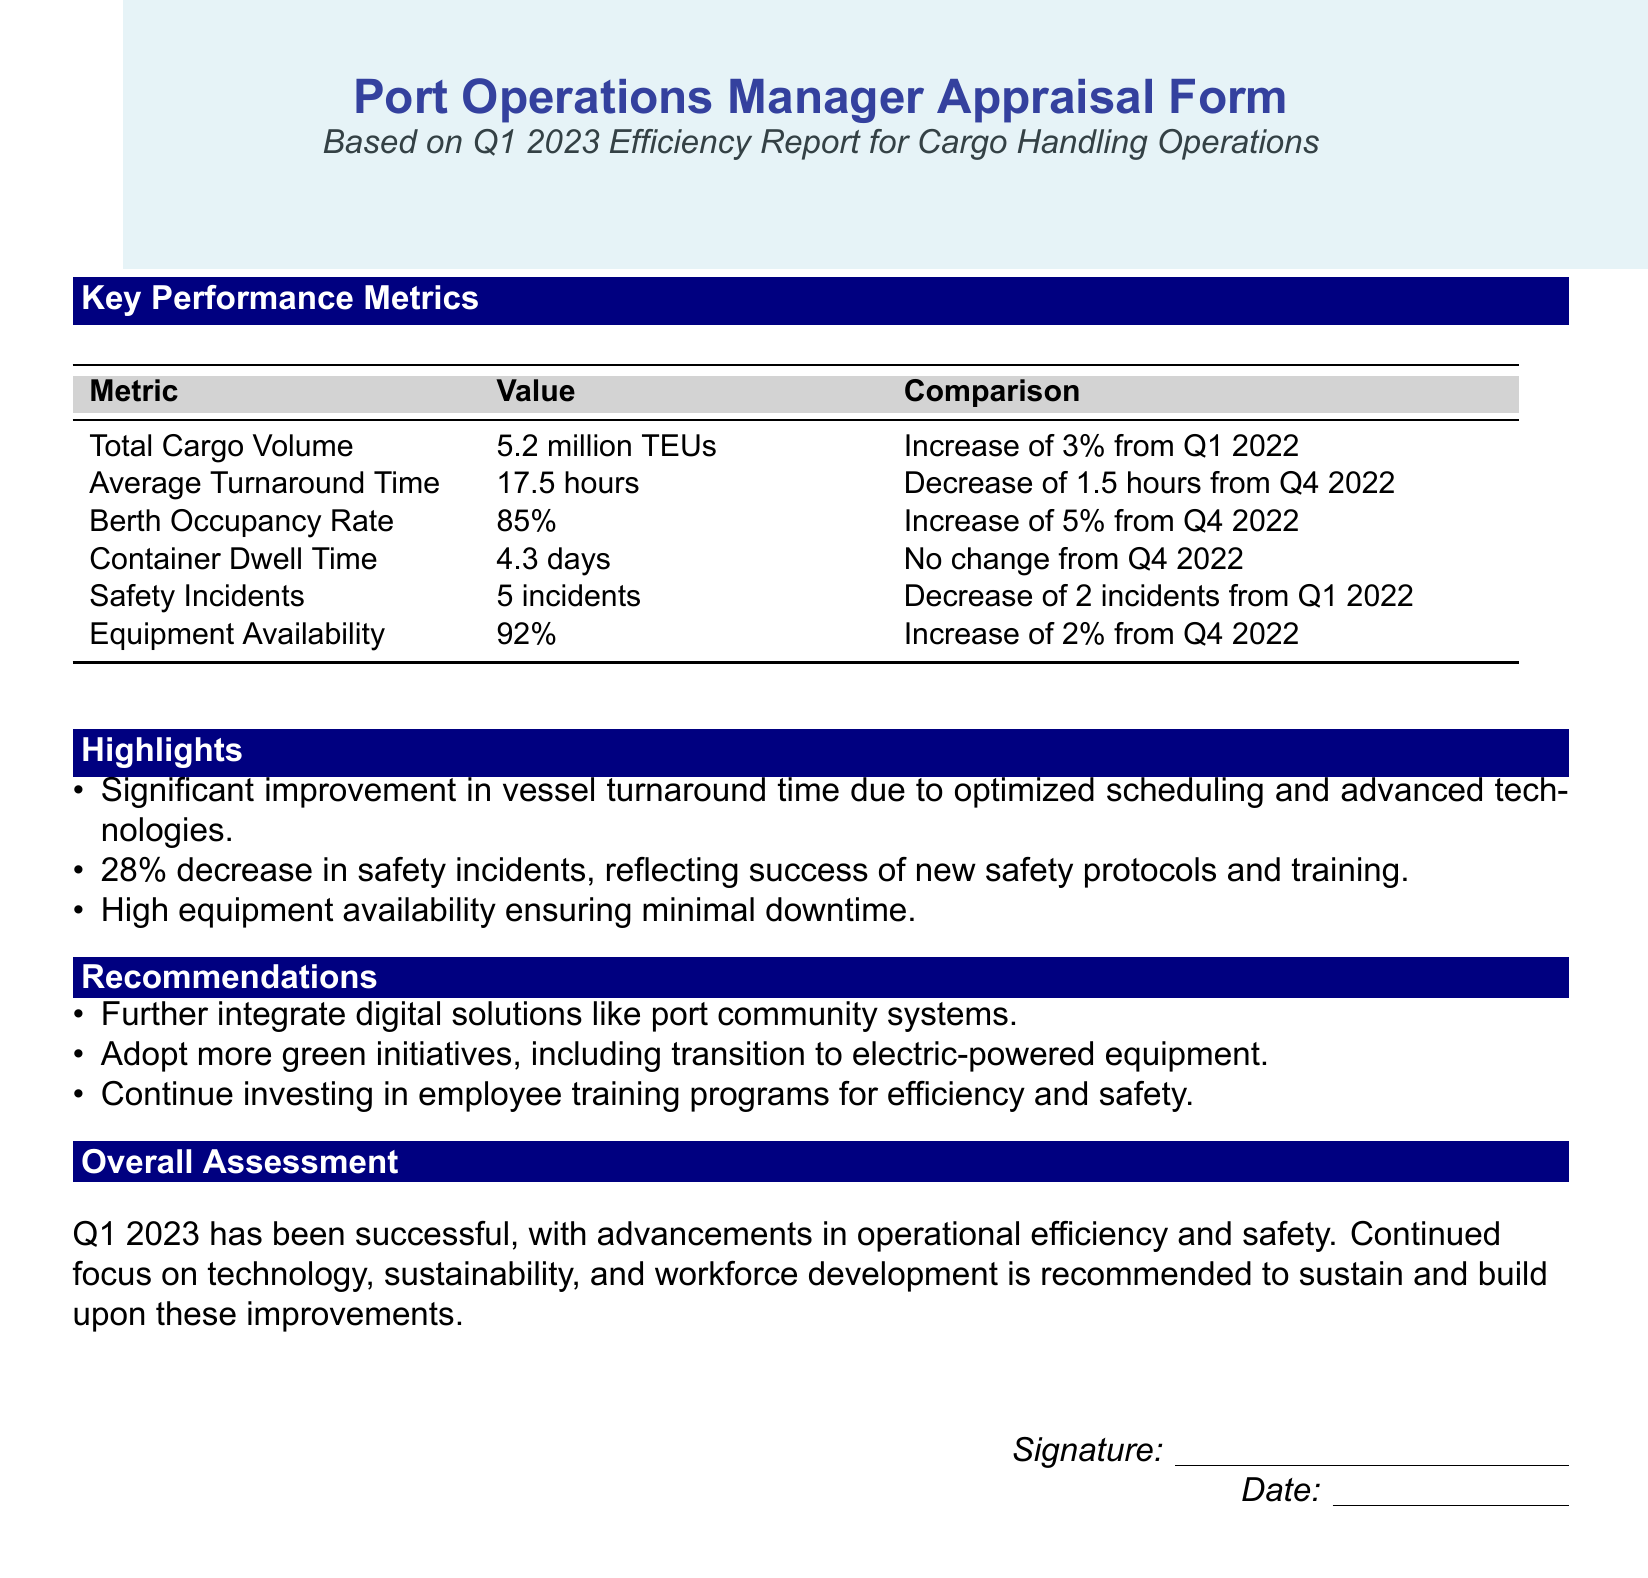What is the total cargo volume? The total cargo volume is reported as 5.2 million TEUs in the document.
Answer: 5.2 million TEUs What is the average turnaround time? The average turnaround time is stated as 17.5 hours in the report.
Answer: 17.5 hours What was the increase in berth occupancy rate? The document indicates an increase of 5% in berth occupancy rate from Q4 2022.
Answer: 5% How many safety incidents were reported? The number of safety incidents reported is 5 incidents.
Answer: 5 incidents What percentage of equipment availability was recorded? Equipment availability is recorded at 92%.
Answer: 92% What improvement percentage was observed in safety incidents? A 28% decrease in safety incidents is highlighted in the report.
Answer: 28% What recommendation is given regarding employee training? The document recommends continuing to invest in employee training programs.
Answer: Continue investing in employee training programs What was the document's overall assessment for Q1 2023? The overall assessment notes Q1 2023 has been successful with advancements in operational efficiency.
Answer: Successful What technology integration is suggested for further improvement? The report recommends further integrating digital solutions like port community systems.
Answer: Digital solutions like port community systems How did the container dwell time change from Q4 2022? The container dwell time showed no change from Q4 2022, as stated in the document.
Answer: No change 